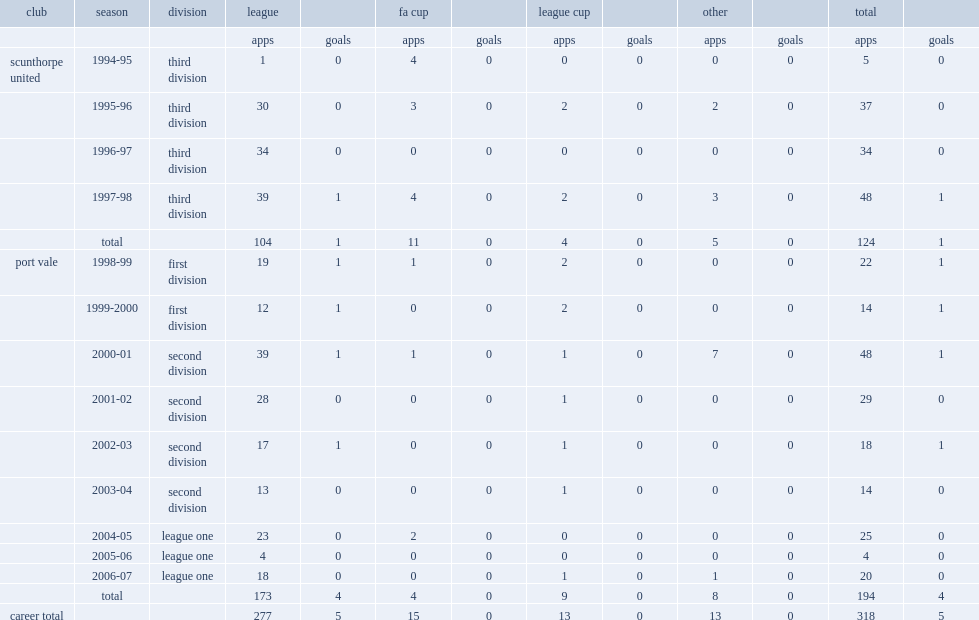How many appearances did michael walsh make in all competitions with scunthorpe united? 124.0. 